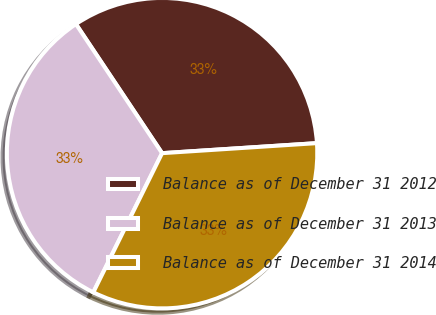Convert chart to OTSL. <chart><loc_0><loc_0><loc_500><loc_500><pie_chart><fcel>Balance as of December 31 2012<fcel>Balance as of December 31 2013<fcel>Balance as of December 31 2014<nl><fcel>33.33%<fcel>33.33%<fcel>33.33%<nl></chart> 